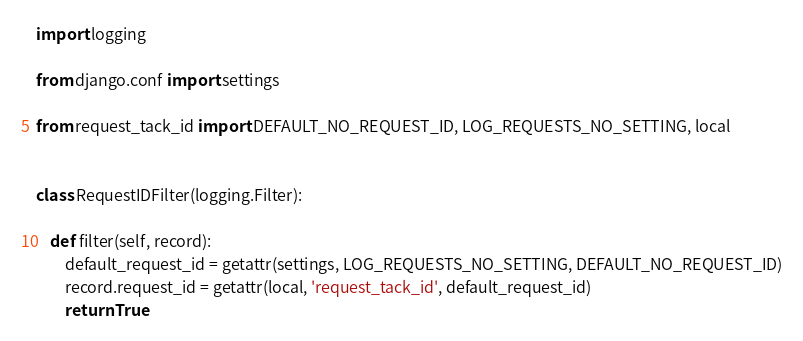<code> <loc_0><loc_0><loc_500><loc_500><_Python_>import logging

from django.conf import settings

from request_tack_id import DEFAULT_NO_REQUEST_ID, LOG_REQUESTS_NO_SETTING, local


class RequestIDFilter(logging.Filter):

    def filter(self, record):
        default_request_id = getattr(settings, LOG_REQUESTS_NO_SETTING, DEFAULT_NO_REQUEST_ID)
        record.request_id = getattr(local, 'request_tack_id', default_request_id)
        return True
</code> 